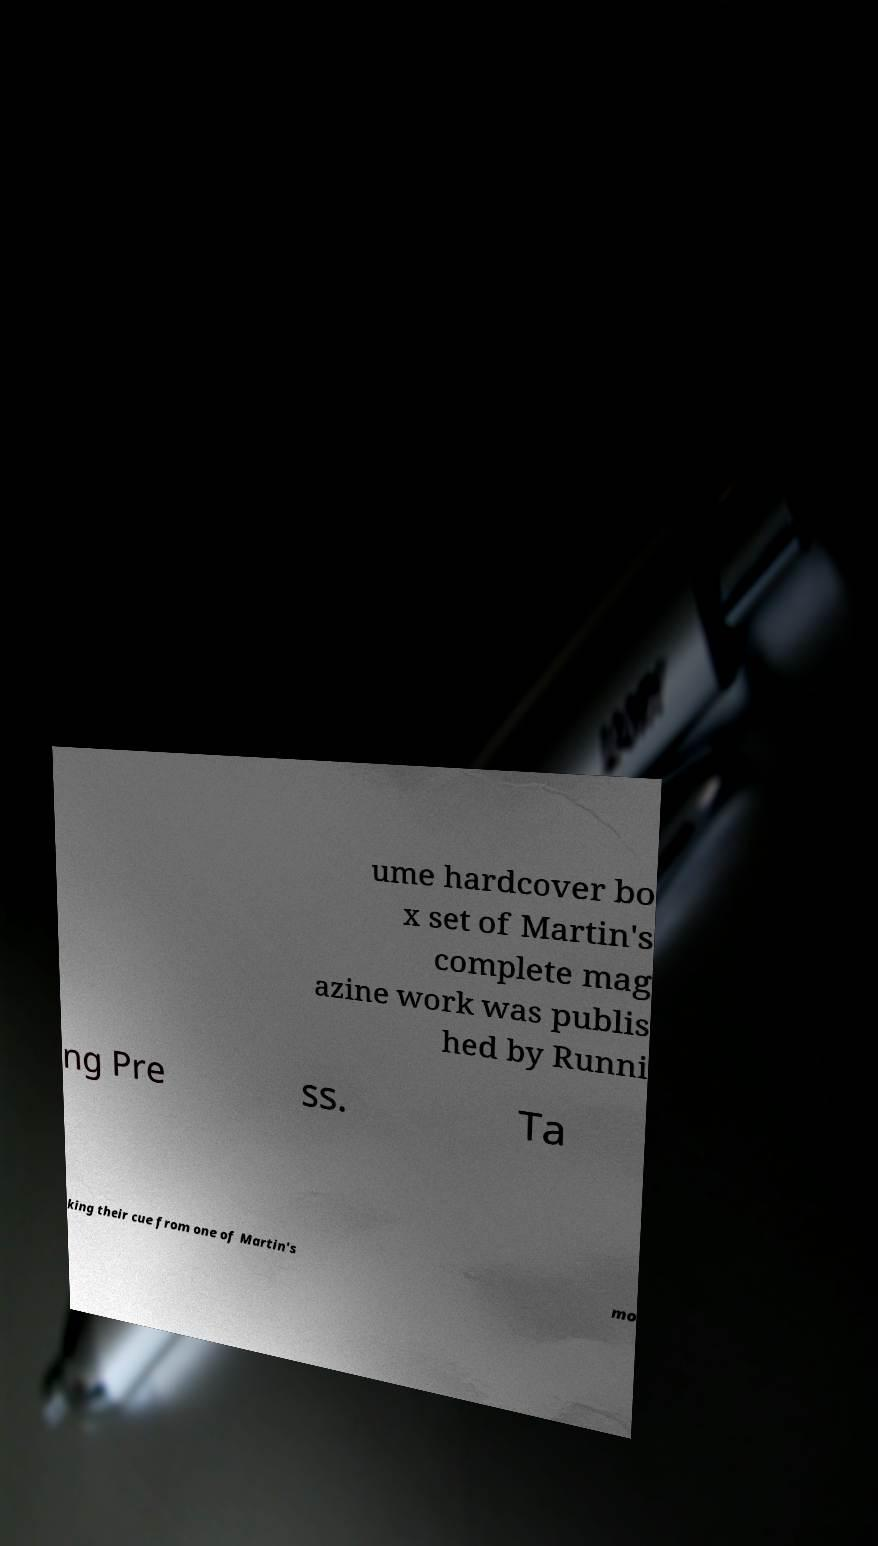For documentation purposes, I need the text within this image transcribed. Could you provide that? ume hardcover bo x set of Martin's complete mag azine work was publis hed by Runni ng Pre ss. Ta king their cue from one of Martin's mo 